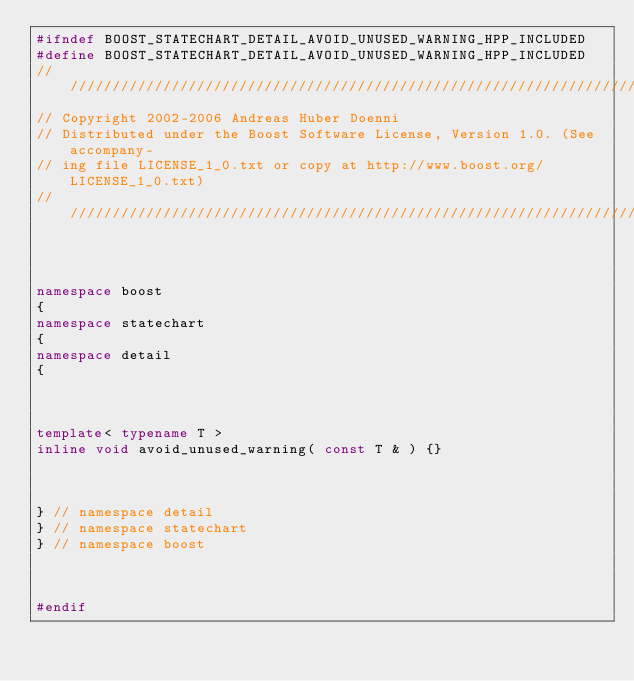Convert code to text. <code><loc_0><loc_0><loc_500><loc_500><_C++_>#ifndef BOOST_STATECHART_DETAIL_AVOID_UNUSED_WARNING_HPP_INCLUDED
#define BOOST_STATECHART_DETAIL_AVOID_UNUSED_WARNING_HPP_INCLUDED
//////////////////////////////////////////////////////////////////////////////
// Copyright 2002-2006 Andreas Huber Doenni
// Distributed under the Boost Software License, Version 1.0. (See accompany-
// ing file LICENSE_1_0.txt or copy at http://www.boost.org/LICENSE_1_0.txt)
//////////////////////////////////////////////////////////////////////////////



namespace boost
{
namespace statechart
{
namespace detail
{



template< typename T >
inline void avoid_unused_warning( const T & ) {}



} // namespace detail
} // namespace statechart
} // namespace boost



#endif
</code> 